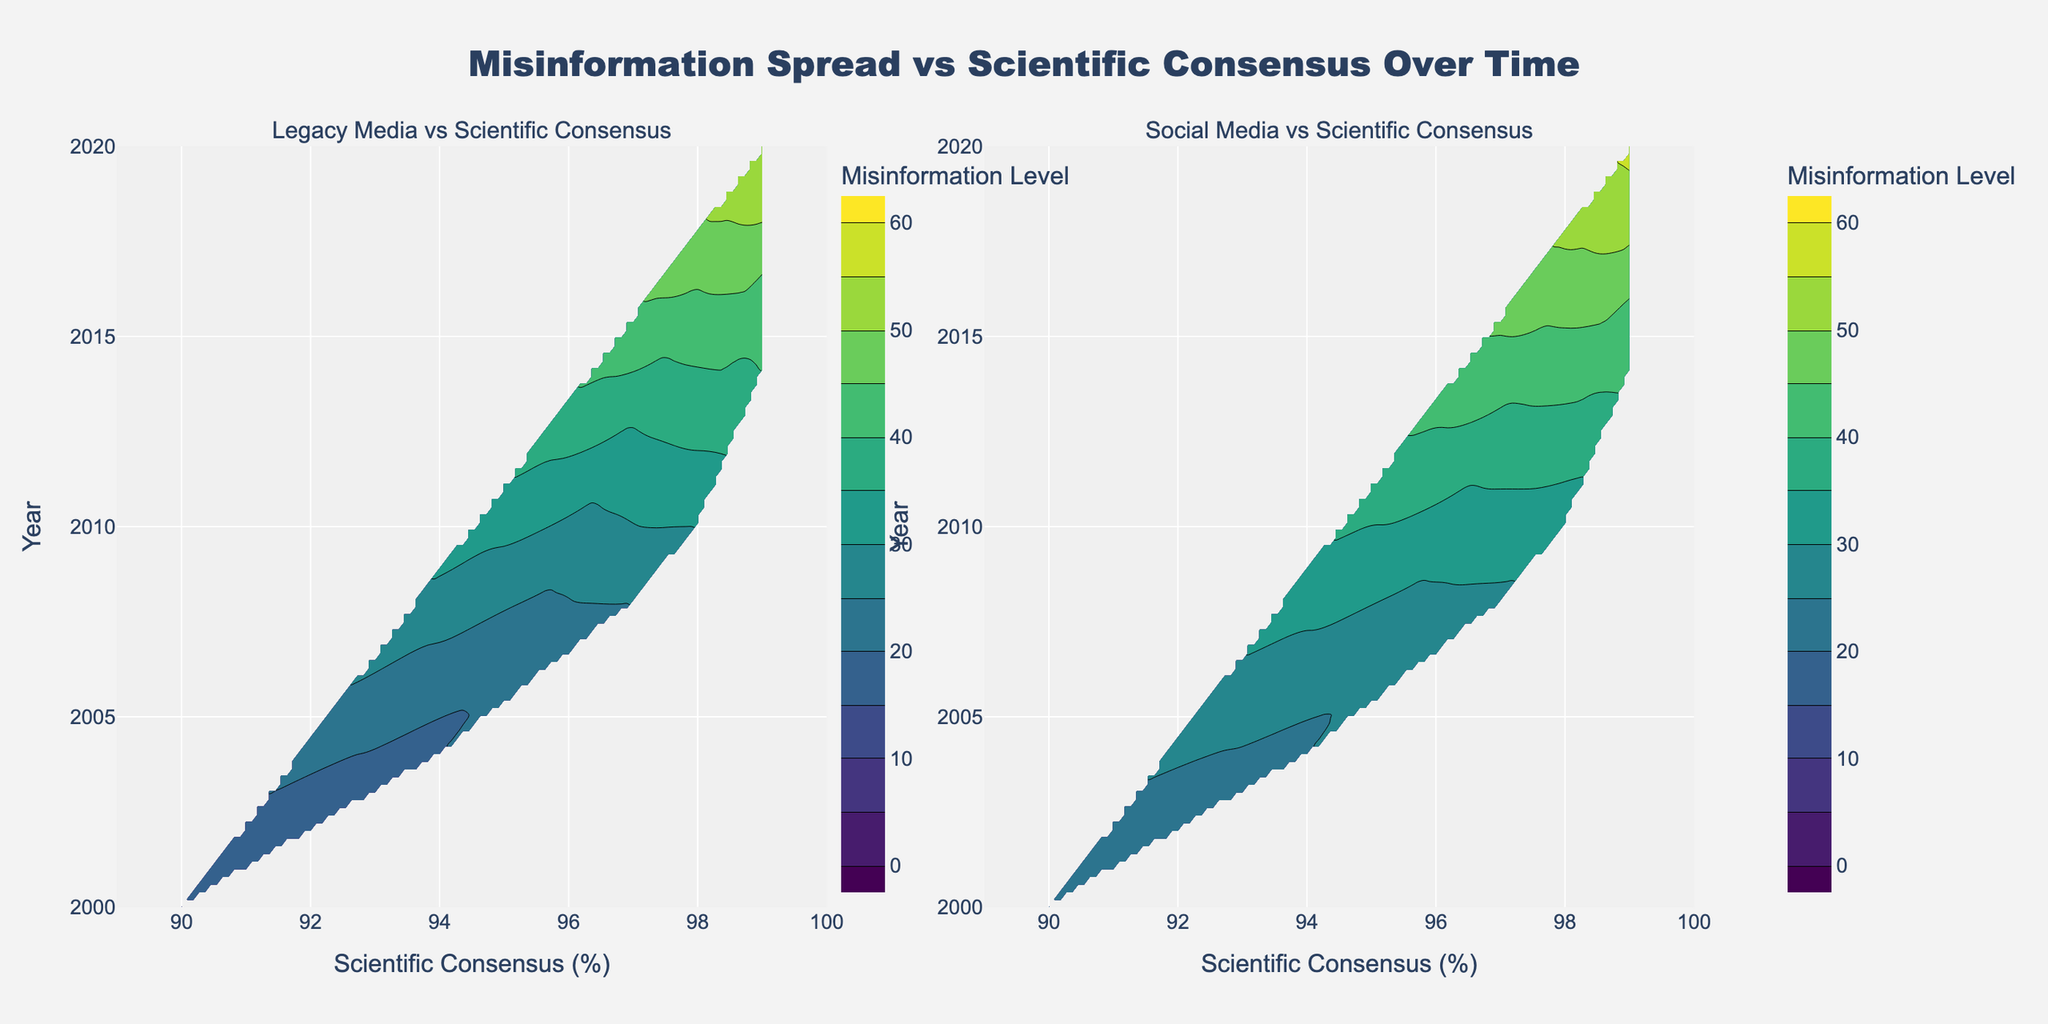What's the title of the figure? The title is text displayed at the top of the plot. In this case, it's centered and reads "Misinformation Spread vs Scientific Consensus Over Time".
Answer: Misinformation Spread vs Scientific Consensus Over Time What information is displayed on the x-axis of the left subplot? Looking at the x-axis of the left subplot, we see the label "Scientific Consensus (%)". This tells us that the horizontal dimension represents the percentage of scientific consensus.
Answer: Scientific Consensus (%) Which subplot has the highest level of misinformation in 2020? By examining the right-hand side of the figure, which represents Social Media, we see the contour levels reach higher values compared to the left-hand side subplot representing Legacy Media.
Answer: Social Media What is the minimum year displayed on the y-axis? Both subplots share the same y-axis, labeled "Year", and begin at 2000 as indicated by the y-axis tick marks.
Answer: 2000 How do the levels of misinformation in Social Media compare to Legacy Media in 2010? Analyzing the contour levels in both subplots around the year 2010 shows that the Social Media subplot has a contour level of around 32, whereas the Legacy Media subplot is around 30. Therefore, Social Media has slightly higher misinformation levels.
Answer: Social Media has slightly higher levels than Legacy Media Which year and media type combination shows the highest misinformation level? Observing the contour plots, the highest levels of misinformation, indicated by the darker colors, occur in 2020 for Social Media, where levels reach around 56.
Answer: 2020, Social Media At what level of scientific consensus does misinformation start to significantly increase in both subplots? Both contour plots show a noticeable increase in misinformation when scientific consensus percentages rise above approximately 95%. This is deduced by observing where the contour lines become denser and the colors change significantly.
Answer: Above 95% scientific consensus What trend can be observed in the spread of misinformation over time relative to scientific consensus? Both subplots demonstrate an increasing trend in misinformation levels over time as the scientific consensus increases. This can be seen from the contour levels becoming increasingly denser and darker from 2000 to 2020.
Answer: Increasing trend over time In which subplot does the misinformation level stay relatively stable between 2000 and 2008? By comparing the two contour plots, the Legacy Media subplot shows relatively stable misinformation levels between 2000 and 2008, while the Social Media plot shows a more noticeable increase during the same period.
Answer: Legacy Media 